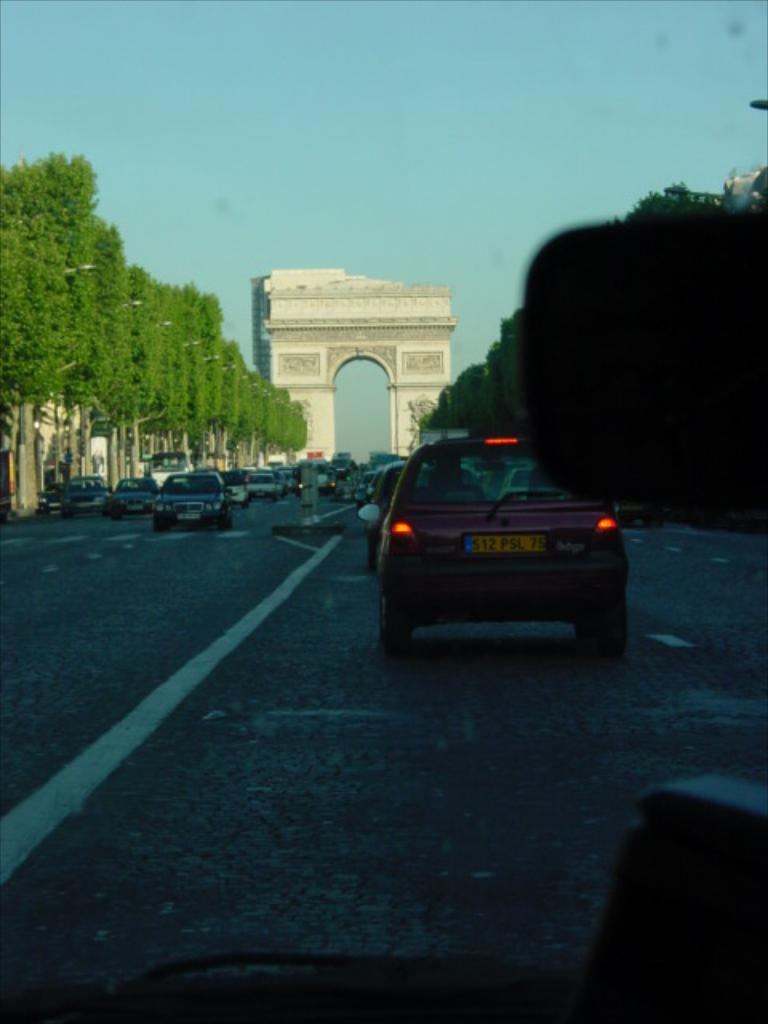What can be seen on the road in the image? There are many vehicles on the road in the image. What type of vegetation is present alongside the road? There are trees on the sides of the road in the image. What is located in the background of the image? There is an arch in the background of the image. What is visible in the sky in the image? The sky is visible in the background of the image. How many people are present in the image? There is no specific person mentioned or visible in the image; it primarily features vehicles, trees, an arch, and the sky. 